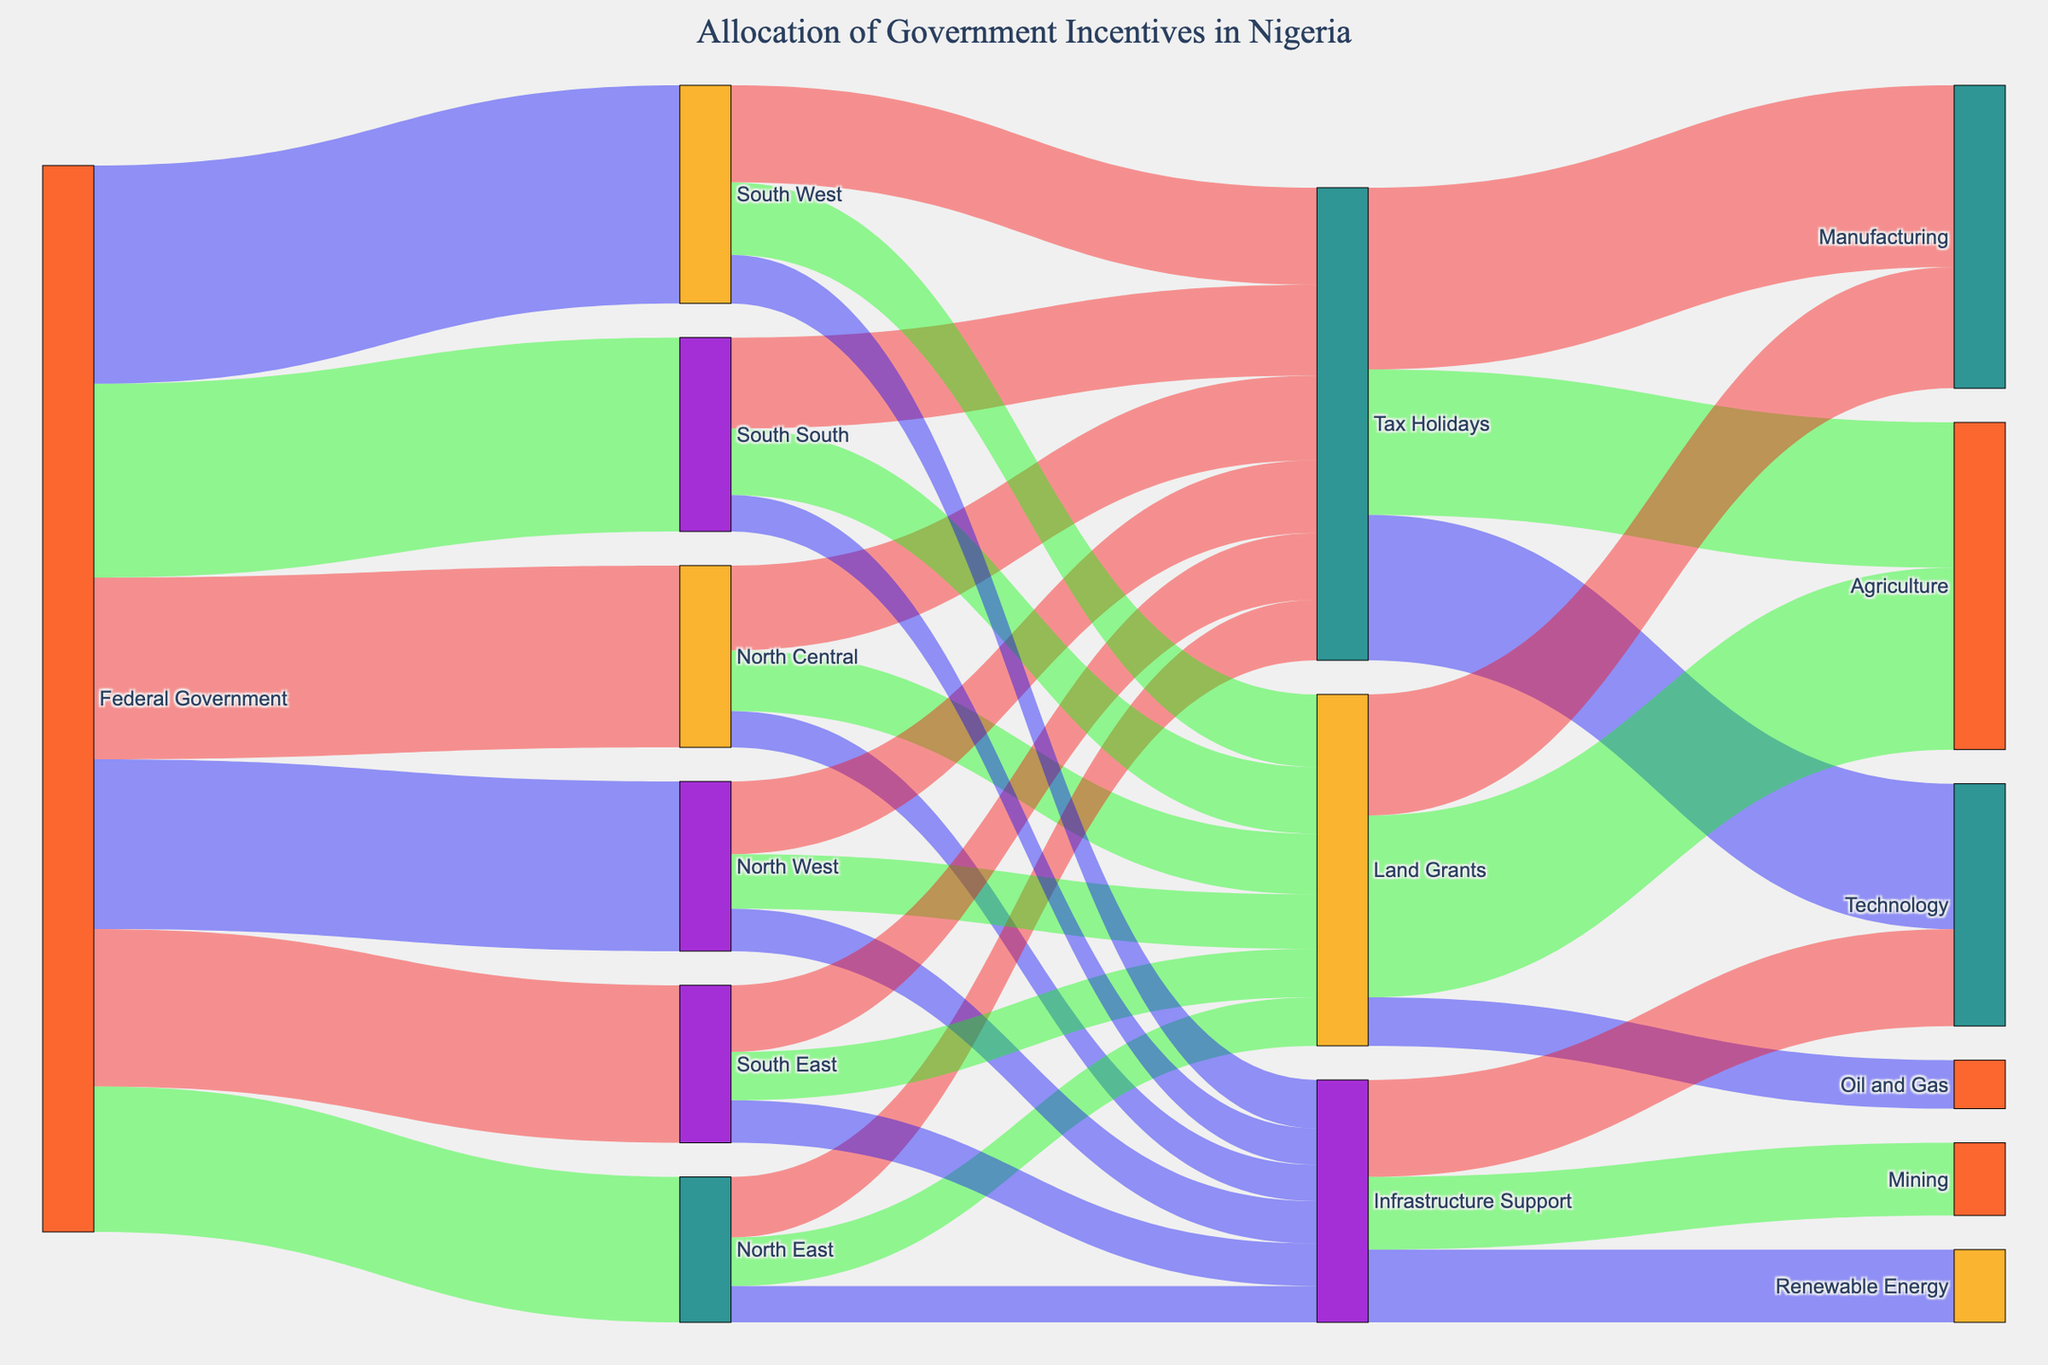What is the title of the Sankey diagram? The title of the diagram is usually displayed at the top, indicating the main subject or focus. In this case, it shows how the government incentives are allocated in Nigeria.
Answer: Allocation of Government Incentives in Nigeria How much incentive was allocated to the South West region? Look for the link coming out from "Federal Government" to "South West." The value associated with this link represents the incentive allocated to the South West region.
Answer: 180 Which region received the least amount of government incentives? Identify the links from "Federal Government" to each region. Compare their values to find the smallest one.
Answer: North East What percentage of the total incentives were allocated to the South East region? Sum all the allocations coming out of "Federal Government" to find the total. Then calculate the percentage for the South East using its value. Sum = 150 + 120 + 140 + 130 + 160 + 180 = 880. Percentage = (130/880) * 100
Answer: 14.77% How much of the incentives in the North Central region were allocated to Infrastructure Support? Look at the link from "North Central" to "Infrastructure Support" to find its value.
Answer: 30 Which type of incentive in the North East has the highest allocation? Compare the values of the links coming out of "North East" to different incentive types to find the highest one.
Answer: Tax Holidays What is the total value allocated to Agriculture through all types of incentives? Sum the values of all links pointing to "Agriculture" from different incentive types ("Tax Holidays," "Land Grants"). Sum = 120 + 150
Answer: 270 How does the total allocation for "Manufacturing" compare to that for "Technology"? Compare the sum of values of links pointing to "Manufacturing" and those pointing to "Technology." Manufacturing = 150 (Tax Holidays) + 100 (Land Grants) = 250. Technology = 120 (Tax Holidays) + 80 (Infrastructure Support) = 200
Answer: Manufacturing is higher by 50 What is the combined value of Infrastructure Support for the South South and South West regions? Add the values of the links from "South South" to "Infrastructure Support" and "South West" to "Infrastructure Support." Sum = 30 + 40
Answer: 70 How many different industries benefit from Infrastructure Support incentives? Identify the unique targets of links coming out of "Infrastructure Support." Count these industries.
Answer: 3 